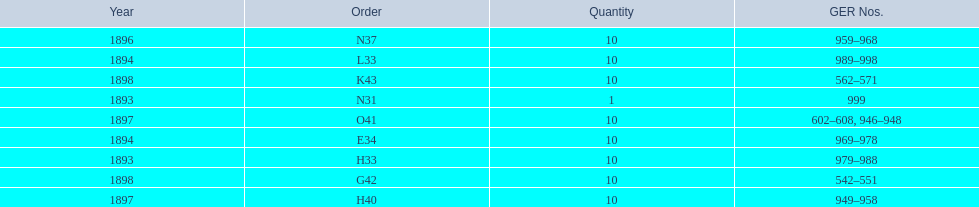What is the number of years with a quantity of 10? 5. 